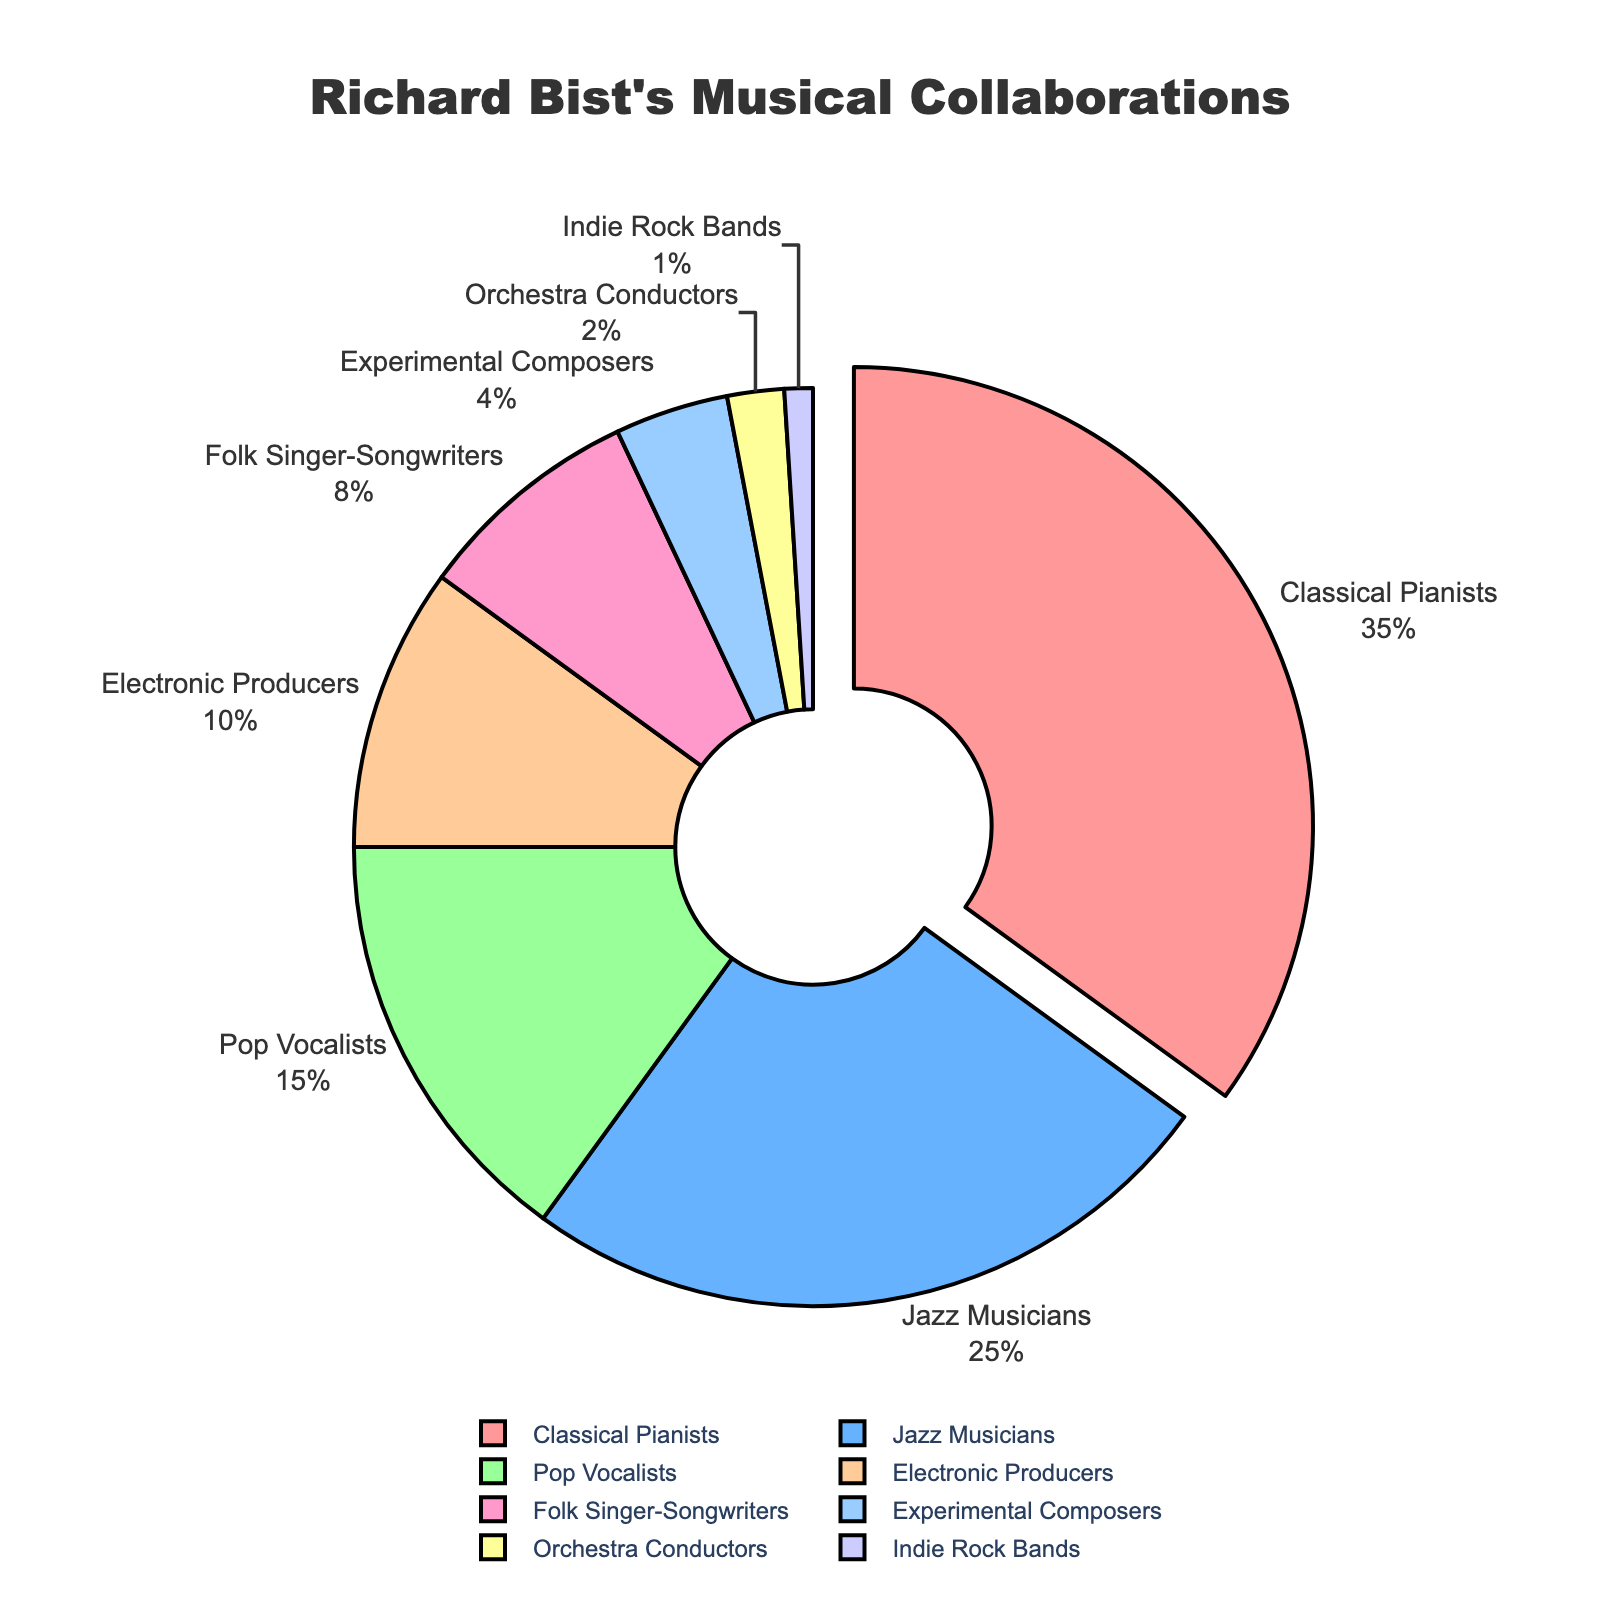Which artist type has the highest percentage of collaborations with Richard Bist? By referring to the pie chart, the segment with the largest portion indicates the highest percentage. The "Classical Pianists" segment is the largest.
Answer: Classical Pianists What percentage of Richard Bist's collaborations involve Jazz Musicians and Pop Vocalists combined? Sum the percentages of Jazz Musicians (25) and Pop Vocalists (15). 25 + 15 = 40
Answer: 40% How much larger is the percentage of collaborations with Classical Pianists compared to Electronic Producers? Subtract the percentage of Electronic Producers (10) from the percentage of Classical Pianists (35). 35 - 10 = 25
Answer: 25% Which artist type has the smallest percentage of collaborations? By referring to the pie chart, the segment with the smallest portion indicates the least percentage. The "Indie Rock Bands" segment is the smallest.
Answer: Indie Rock Bands What is the combined percentage for Folk Singer-Songwriters, Experimental Composers, and Orchestra Conductors? Sum the percentages of Folk Singer-Songwriters (8), Experimental Composers (4), and Orchestra Conductors (2). 8 + 4 + 2 = 14
Answer: 14% Are Jazz Musicians or Electronic Producers more frequently collaborating with Richard Bist? By comparing the segments of Jazz Musicians and Electronic Producers, the Jazz Musicians segment is larger.
Answer: Jazz Musicians If the chart were to be simplified to only three categories: 'Classical Pianists', 'Jazz Musicians', and 'Others', what percentage would the 'Others' category represent? Sum the percentages of all artist types except for Classical Pianists (35) and Jazz Musicians (25). 'Others' include Pop Vocalists (15), Electronic Producers (10), Folk Singer-Songwriters (8), Experimental Composers (4), Orchestra Conductors (2), and Indie Rock Bands (1). 15 + 10 + 8 + 4 + 2 + 1 = 40
Answer: 40% Which artist types have percentages that fall between 5% and 15% of Richard Bist's collaborations? By referring to the pie chart, the artist types within that range include Pop Vocalists (15) and Folk Singer-Songwriters (8).
Answer: Pop Vocalists, Folk Singer-Songwriters What is the difference in percentage between Richard Bist's collaborations with Experimental Composers and Orchestra Conductors? Subtract the percentage of Orchestra Conductors (2) from the percentage of Experimental Composers (4). 4 - 2 = 2
Answer: 2% What is the segment color for the artist type with a percentage of 25%? By referring to the pie chart, the segment for Jazz Musicians has a percentage of 25%, and its color is blue.
Answer: Blue 